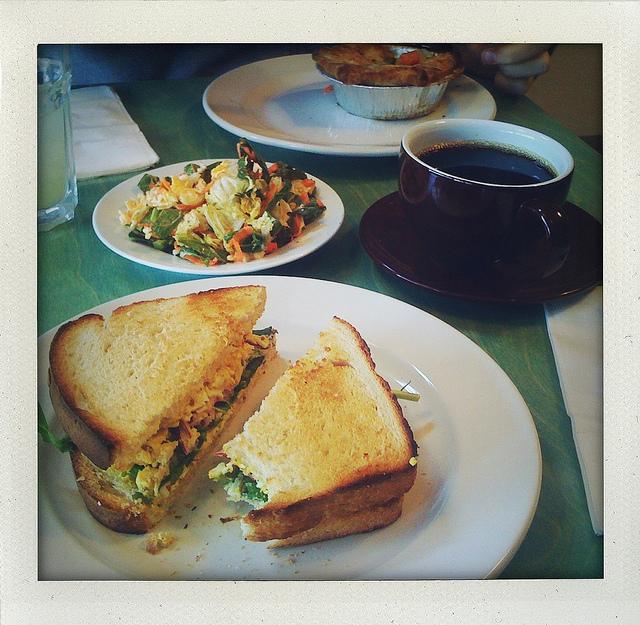What is the design on the platter to the rear?
Be succinct. Solid white. What vegetable is in the dish in the back?
Be succinct. Salad. What is the food on the plate called?
Short answer required. Sandwich. Are there any ribbons in the picture?
Concise answer only. No. What kind of design is on the table cloth?
Give a very brief answer. Floral. How many plates are pictured?
Quick response, please. 4. What is in the cup?
Keep it brief. Coffee. Is the cup full?
Write a very short answer. Yes. What is green on these sandwiches?
Be succinct. Lettuce. Are all of the foods composed of the same veggie?
Be succinct. No. 